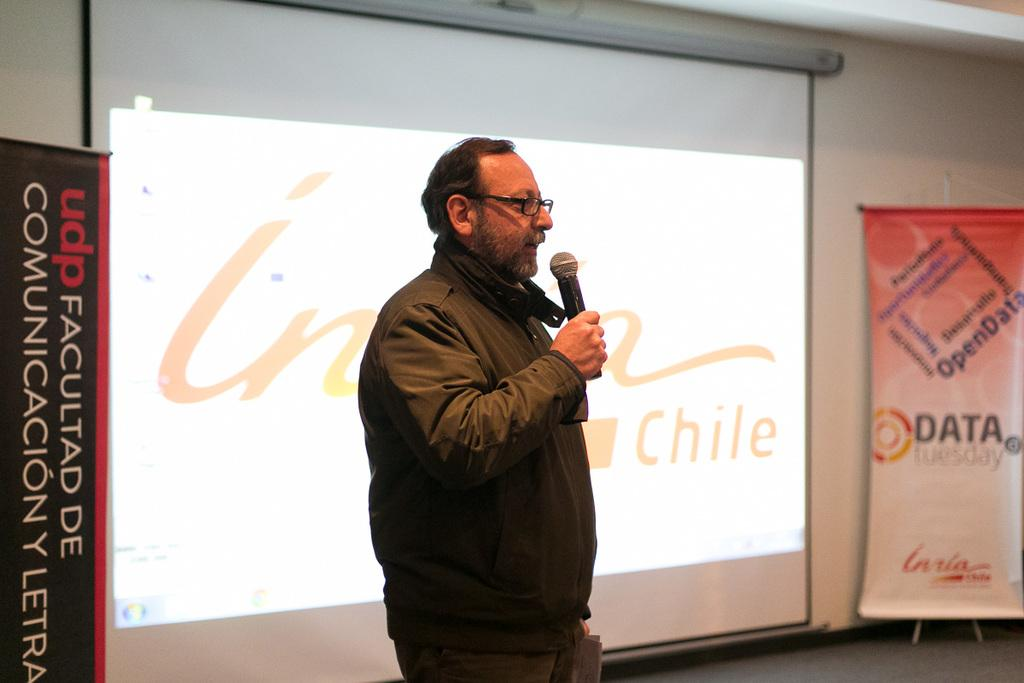<image>
Provide a brief description of the given image. A man stands in front of a white board to the left of the word Chile. 